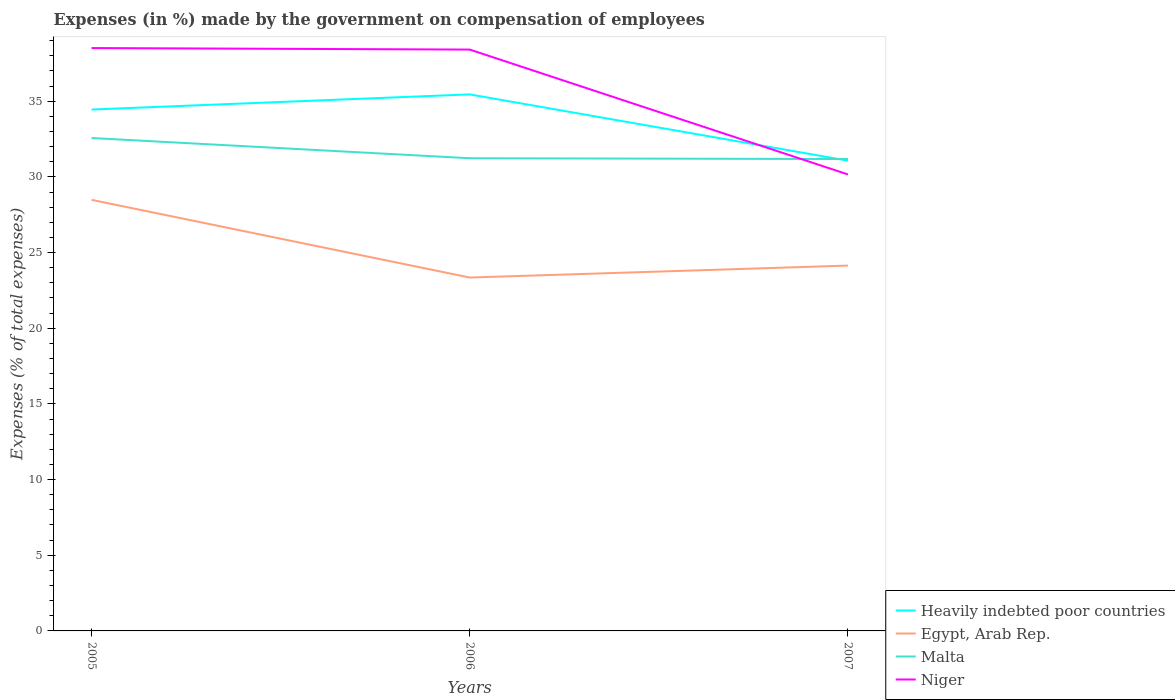Does the line corresponding to Egypt, Arab Rep. intersect with the line corresponding to Heavily indebted poor countries?
Ensure brevity in your answer.  No. Across all years, what is the maximum percentage of expenses made by the government on compensation of employees in Malta?
Your answer should be compact. 31.18. In which year was the percentage of expenses made by the government on compensation of employees in Egypt, Arab Rep. maximum?
Give a very brief answer. 2006. What is the total percentage of expenses made by the government on compensation of employees in Niger in the graph?
Offer a very short reply. 0.1. What is the difference between the highest and the second highest percentage of expenses made by the government on compensation of employees in Niger?
Your answer should be very brief. 8.35. What is the difference between the highest and the lowest percentage of expenses made by the government on compensation of employees in Heavily indebted poor countries?
Ensure brevity in your answer.  2. Is the percentage of expenses made by the government on compensation of employees in Heavily indebted poor countries strictly greater than the percentage of expenses made by the government on compensation of employees in Niger over the years?
Offer a terse response. No. How many years are there in the graph?
Keep it short and to the point. 3. What is the difference between two consecutive major ticks on the Y-axis?
Ensure brevity in your answer.  5. Where does the legend appear in the graph?
Your response must be concise. Bottom right. How are the legend labels stacked?
Your answer should be compact. Vertical. What is the title of the graph?
Ensure brevity in your answer.  Expenses (in %) made by the government on compensation of employees. Does "St. Lucia" appear as one of the legend labels in the graph?
Keep it short and to the point. No. What is the label or title of the X-axis?
Keep it short and to the point. Years. What is the label or title of the Y-axis?
Make the answer very short. Expenses (% of total expenses). What is the Expenses (% of total expenses) of Heavily indebted poor countries in 2005?
Offer a very short reply. 34.45. What is the Expenses (% of total expenses) of Egypt, Arab Rep. in 2005?
Your response must be concise. 28.48. What is the Expenses (% of total expenses) in Malta in 2005?
Provide a short and direct response. 32.57. What is the Expenses (% of total expenses) of Niger in 2005?
Give a very brief answer. 38.51. What is the Expenses (% of total expenses) in Heavily indebted poor countries in 2006?
Your answer should be compact. 35.45. What is the Expenses (% of total expenses) of Egypt, Arab Rep. in 2006?
Keep it short and to the point. 23.35. What is the Expenses (% of total expenses) of Malta in 2006?
Give a very brief answer. 31.23. What is the Expenses (% of total expenses) in Niger in 2006?
Offer a terse response. 38.41. What is the Expenses (% of total expenses) of Heavily indebted poor countries in 2007?
Keep it short and to the point. 31.07. What is the Expenses (% of total expenses) of Egypt, Arab Rep. in 2007?
Give a very brief answer. 24.14. What is the Expenses (% of total expenses) in Malta in 2007?
Make the answer very short. 31.18. What is the Expenses (% of total expenses) of Niger in 2007?
Provide a succinct answer. 30.16. Across all years, what is the maximum Expenses (% of total expenses) in Heavily indebted poor countries?
Provide a short and direct response. 35.45. Across all years, what is the maximum Expenses (% of total expenses) of Egypt, Arab Rep.?
Ensure brevity in your answer.  28.48. Across all years, what is the maximum Expenses (% of total expenses) in Malta?
Your answer should be very brief. 32.57. Across all years, what is the maximum Expenses (% of total expenses) in Niger?
Provide a short and direct response. 38.51. Across all years, what is the minimum Expenses (% of total expenses) in Heavily indebted poor countries?
Give a very brief answer. 31.07. Across all years, what is the minimum Expenses (% of total expenses) of Egypt, Arab Rep.?
Your answer should be very brief. 23.35. Across all years, what is the minimum Expenses (% of total expenses) in Malta?
Offer a terse response. 31.18. Across all years, what is the minimum Expenses (% of total expenses) in Niger?
Ensure brevity in your answer.  30.16. What is the total Expenses (% of total expenses) of Heavily indebted poor countries in the graph?
Your answer should be very brief. 100.98. What is the total Expenses (% of total expenses) of Egypt, Arab Rep. in the graph?
Your answer should be very brief. 75.98. What is the total Expenses (% of total expenses) in Malta in the graph?
Your answer should be very brief. 94.98. What is the total Expenses (% of total expenses) in Niger in the graph?
Give a very brief answer. 107.09. What is the difference between the Expenses (% of total expenses) in Heavily indebted poor countries in 2005 and that in 2006?
Your response must be concise. -1. What is the difference between the Expenses (% of total expenses) of Egypt, Arab Rep. in 2005 and that in 2006?
Offer a very short reply. 5.13. What is the difference between the Expenses (% of total expenses) of Malta in 2005 and that in 2006?
Provide a short and direct response. 1.34. What is the difference between the Expenses (% of total expenses) of Niger in 2005 and that in 2006?
Keep it short and to the point. 0.1. What is the difference between the Expenses (% of total expenses) in Heavily indebted poor countries in 2005 and that in 2007?
Ensure brevity in your answer.  3.38. What is the difference between the Expenses (% of total expenses) in Egypt, Arab Rep. in 2005 and that in 2007?
Your answer should be compact. 4.34. What is the difference between the Expenses (% of total expenses) of Malta in 2005 and that in 2007?
Offer a terse response. 1.39. What is the difference between the Expenses (% of total expenses) of Niger in 2005 and that in 2007?
Provide a succinct answer. 8.35. What is the difference between the Expenses (% of total expenses) of Heavily indebted poor countries in 2006 and that in 2007?
Offer a very short reply. 4.38. What is the difference between the Expenses (% of total expenses) in Egypt, Arab Rep. in 2006 and that in 2007?
Your answer should be compact. -0.79. What is the difference between the Expenses (% of total expenses) of Malta in 2006 and that in 2007?
Provide a succinct answer. 0.05. What is the difference between the Expenses (% of total expenses) of Niger in 2006 and that in 2007?
Your response must be concise. 8.25. What is the difference between the Expenses (% of total expenses) of Heavily indebted poor countries in 2005 and the Expenses (% of total expenses) of Egypt, Arab Rep. in 2006?
Give a very brief answer. 11.1. What is the difference between the Expenses (% of total expenses) of Heavily indebted poor countries in 2005 and the Expenses (% of total expenses) of Malta in 2006?
Your response must be concise. 3.22. What is the difference between the Expenses (% of total expenses) of Heavily indebted poor countries in 2005 and the Expenses (% of total expenses) of Niger in 2006?
Your response must be concise. -3.96. What is the difference between the Expenses (% of total expenses) in Egypt, Arab Rep. in 2005 and the Expenses (% of total expenses) in Malta in 2006?
Keep it short and to the point. -2.75. What is the difference between the Expenses (% of total expenses) in Egypt, Arab Rep. in 2005 and the Expenses (% of total expenses) in Niger in 2006?
Make the answer very short. -9.93. What is the difference between the Expenses (% of total expenses) of Malta in 2005 and the Expenses (% of total expenses) of Niger in 2006?
Keep it short and to the point. -5.84. What is the difference between the Expenses (% of total expenses) in Heavily indebted poor countries in 2005 and the Expenses (% of total expenses) in Egypt, Arab Rep. in 2007?
Ensure brevity in your answer.  10.31. What is the difference between the Expenses (% of total expenses) in Heavily indebted poor countries in 2005 and the Expenses (% of total expenses) in Malta in 2007?
Offer a terse response. 3.27. What is the difference between the Expenses (% of total expenses) of Heavily indebted poor countries in 2005 and the Expenses (% of total expenses) of Niger in 2007?
Keep it short and to the point. 4.29. What is the difference between the Expenses (% of total expenses) in Egypt, Arab Rep. in 2005 and the Expenses (% of total expenses) in Malta in 2007?
Your response must be concise. -2.69. What is the difference between the Expenses (% of total expenses) in Egypt, Arab Rep. in 2005 and the Expenses (% of total expenses) in Niger in 2007?
Make the answer very short. -1.68. What is the difference between the Expenses (% of total expenses) of Malta in 2005 and the Expenses (% of total expenses) of Niger in 2007?
Your response must be concise. 2.41. What is the difference between the Expenses (% of total expenses) of Heavily indebted poor countries in 2006 and the Expenses (% of total expenses) of Egypt, Arab Rep. in 2007?
Provide a short and direct response. 11.31. What is the difference between the Expenses (% of total expenses) in Heavily indebted poor countries in 2006 and the Expenses (% of total expenses) in Malta in 2007?
Keep it short and to the point. 4.27. What is the difference between the Expenses (% of total expenses) in Heavily indebted poor countries in 2006 and the Expenses (% of total expenses) in Niger in 2007?
Give a very brief answer. 5.29. What is the difference between the Expenses (% of total expenses) in Egypt, Arab Rep. in 2006 and the Expenses (% of total expenses) in Malta in 2007?
Offer a terse response. -7.83. What is the difference between the Expenses (% of total expenses) of Egypt, Arab Rep. in 2006 and the Expenses (% of total expenses) of Niger in 2007?
Your response must be concise. -6.81. What is the difference between the Expenses (% of total expenses) in Malta in 2006 and the Expenses (% of total expenses) in Niger in 2007?
Make the answer very short. 1.07. What is the average Expenses (% of total expenses) of Heavily indebted poor countries per year?
Offer a very short reply. 33.66. What is the average Expenses (% of total expenses) in Egypt, Arab Rep. per year?
Your response must be concise. 25.33. What is the average Expenses (% of total expenses) in Malta per year?
Provide a short and direct response. 31.66. What is the average Expenses (% of total expenses) in Niger per year?
Provide a succinct answer. 35.7. In the year 2005, what is the difference between the Expenses (% of total expenses) in Heavily indebted poor countries and Expenses (% of total expenses) in Egypt, Arab Rep.?
Give a very brief answer. 5.97. In the year 2005, what is the difference between the Expenses (% of total expenses) of Heavily indebted poor countries and Expenses (% of total expenses) of Malta?
Your response must be concise. 1.88. In the year 2005, what is the difference between the Expenses (% of total expenses) of Heavily indebted poor countries and Expenses (% of total expenses) of Niger?
Keep it short and to the point. -4.06. In the year 2005, what is the difference between the Expenses (% of total expenses) in Egypt, Arab Rep. and Expenses (% of total expenses) in Malta?
Ensure brevity in your answer.  -4.08. In the year 2005, what is the difference between the Expenses (% of total expenses) of Egypt, Arab Rep. and Expenses (% of total expenses) of Niger?
Keep it short and to the point. -10.03. In the year 2005, what is the difference between the Expenses (% of total expenses) of Malta and Expenses (% of total expenses) of Niger?
Your answer should be very brief. -5.94. In the year 2006, what is the difference between the Expenses (% of total expenses) in Heavily indebted poor countries and Expenses (% of total expenses) in Egypt, Arab Rep.?
Keep it short and to the point. 12.1. In the year 2006, what is the difference between the Expenses (% of total expenses) in Heavily indebted poor countries and Expenses (% of total expenses) in Malta?
Keep it short and to the point. 4.22. In the year 2006, what is the difference between the Expenses (% of total expenses) of Heavily indebted poor countries and Expenses (% of total expenses) of Niger?
Offer a terse response. -2.96. In the year 2006, what is the difference between the Expenses (% of total expenses) in Egypt, Arab Rep. and Expenses (% of total expenses) in Malta?
Offer a very short reply. -7.88. In the year 2006, what is the difference between the Expenses (% of total expenses) of Egypt, Arab Rep. and Expenses (% of total expenses) of Niger?
Give a very brief answer. -15.06. In the year 2006, what is the difference between the Expenses (% of total expenses) of Malta and Expenses (% of total expenses) of Niger?
Give a very brief answer. -7.18. In the year 2007, what is the difference between the Expenses (% of total expenses) of Heavily indebted poor countries and Expenses (% of total expenses) of Egypt, Arab Rep.?
Give a very brief answer. 6.93. In the year 2007, what is the difference between the Expenses (% of total expenses) of Heavily indebted poor countries and Expenses (% of total expenses) of Malta?
Ensure brevity in your answer.  -0.11. In the year 2007, what is the difference between the Expenses (% of total expenses) in Heavily indebted poor countries and Expenses (% of total expenses) in Niger?
Offer a terse response. 0.91. In the year 2007, what is the difference between the Expenses (% of total expenses) in Egypt, Arab Rep. and Expenses (% of total expenses) in Malta?
Your response must be concise. -7.04. In the year 2007, what is the difference between the Expenses (% of total expenses) of Egypt, Arab Rep. and Expenses (% of total expenses) of Niger?
Provide a succinct answer. -6.02. In the year 2007, what is the difference between the Expenses (% of total expenses) in Malta and Expenses (% of total expenses) in Niger?
Your answer should be compact. 1.02. What is the ratio of the Expenses (% of total expenses) in Heavily indebted poor countries in 2005 to that in 2006?
Offer a very short reply. 0.97. What is the ratio of the Expenses (% of total expenses) in Egypt, Arab Rep. in 2005 to that in 2006?
Ensure brevity in your answer.  1.22. What is the ratio of the Expenses (% of total expenses) in Malta in 2005 to that in 2006?
Your answer should be compact. 1.04. What is the ratio of the Expenses (% of total expenses) in Heavily indebted poor countries in 2005 to that in 2007?
Keep it short and to the point. 1.11. What is the ratio of the Expenses (% of total expenses) in Egypt, Arab Rep. in 2005 to that in 2007?
Give a very brief answer. 1.18. What is the ratio of the Expenses (% of total expenses) of Malta in 2005 to that in 2007?
Offer a terse response. 1.04. What is the ratio of the Expenses (% of total expenses) in Niger in 2005 to that in 2007?
Make the answer very short. 1.28. What is the ratio of the Expenses (% of total expenses) of Heavily indebted poor countries in 2006 to that in 2007?
Give a very brief answer. 1.14. What is the ratio of the Expenses (% of total expenses) of Egypt, Arab Rep. in 2006 to that in 2007?
Your answer should be very brief. 0.97. What is the ratio of the Expenses (% of total expenses) of Niger in 2006 to that in 2007?
Offer a terse response. 1.27. What is the difference between the highest and the second highest Expenses (% of total expenses) of Heavily indebted poor countries?
Offer a very short reply. 1. What is the difference between the highest and the second highest Expenses (% of total expenses) in Egypt, Arab Rep.?
Your answer should be very brief. 4.34. What is the difference between the highest and the second highest Expenses (% of total expenses) of Malta?
Ensure brevity in your answer.  1.34. What is the difference between the highest and the second highest Expenses (% of total expenses) of Niger?
Give a very brief answer. 0.1. What is the difference between the highest and the lowest Expenses (% of total expenses) of Heavily indebted poor countries?
Your answer should be compact. 4.38. What is the difference between the highest and the lowest Expenses (% of total expenses) in Egypt, Arab Rep.?
Offer a terse response. 5.13. What is the difference between the highest and the lowest Expenses (% of total expenses) of Malta?
Provide a succinct answer. 1.39. What is the difference between the highest and the lowest Expenses (% of total expenses) in Niger?
Make the answer very short. 8.35. 